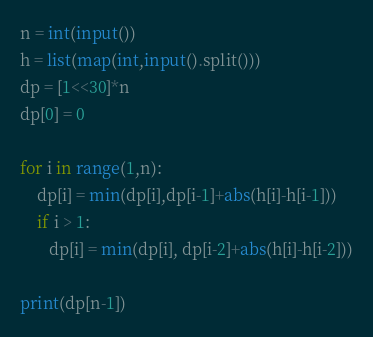<code> <loc_0><loc_0><loc_500><loc_500><_Python_>n = int(input())
h = list(map(int,input().split()))
dp = [1<<30]*n
dp[0] = 0 

for i in range(1,n):
    dp[i] = min(dp[i],dp[i-1]+abs(h[i]-h[i-1]))
    if i > 1:
       dp[i] = min(dp[i], dp[i-2]+abs(h[i]-h[i-2]))
        
print(dp[n-1])
</code> 